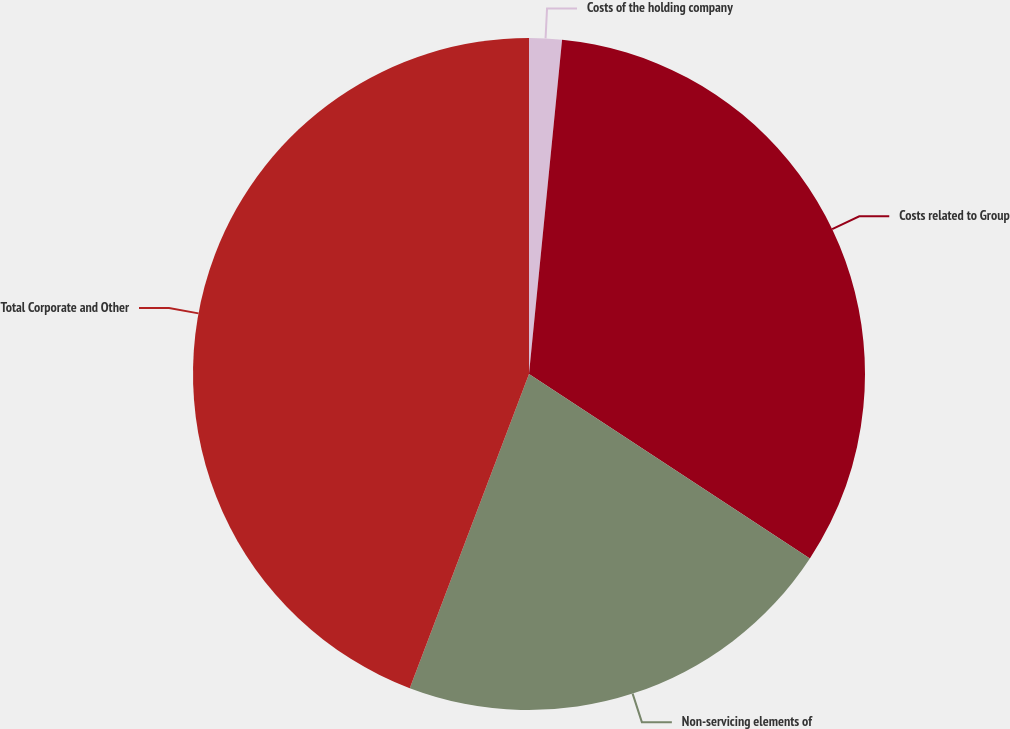Convert chart. <chart><loc_0><loc_0><loc_500><loc_500><pie_chart><fcel>Costs of the holding company<fcel>Costs related to Group<fcel>Non-servicing elements of<fcel>Total Corporate and Other<nl><fcel>1.57%<fcel>32.68%<fcel>21.53%<fcel>44.23%<nl></chart> 